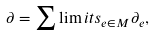<formula> <loc_0><loc_0><loc_500><loc_500>\partial = \sum \lim i t s _ { e \in M } \partial _ { e } ,</formula> 